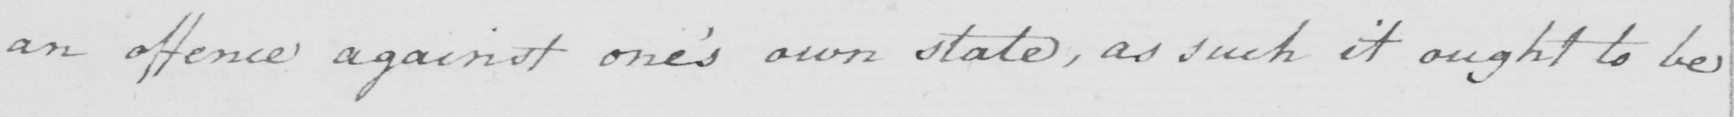Please provide the text content of this handwritten line. an offence against one ' s own state , as such it ought to be 